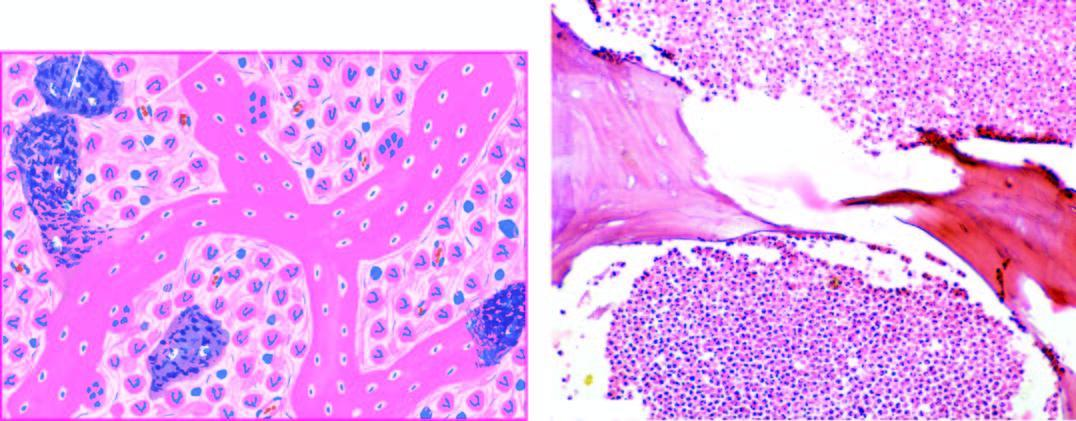what shows necrotic bone and extensive purulent inflammatory exudate?
Answer the question using a single word or phrase. Histologic appearance 